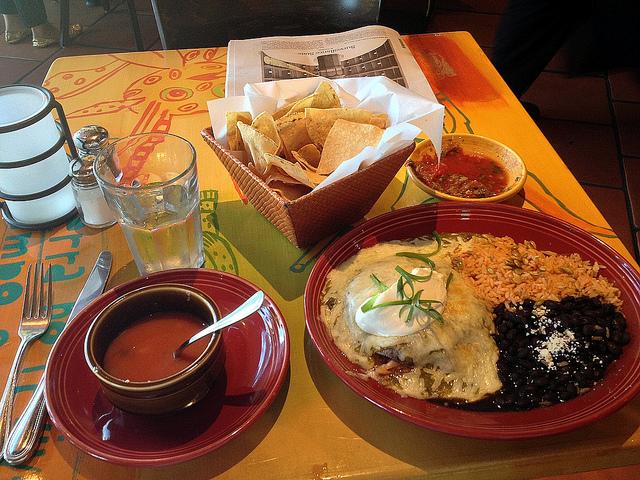What utensils can be seen?
Keep it brief. Fork and knife. Where are the chips?
Short answer required. Basket. Is there  anyone eating?
Concise answer only. No. What is for dinner?
Quick response, please. Mexican food. How many dishes on the table?
Quick response, please. 2. 